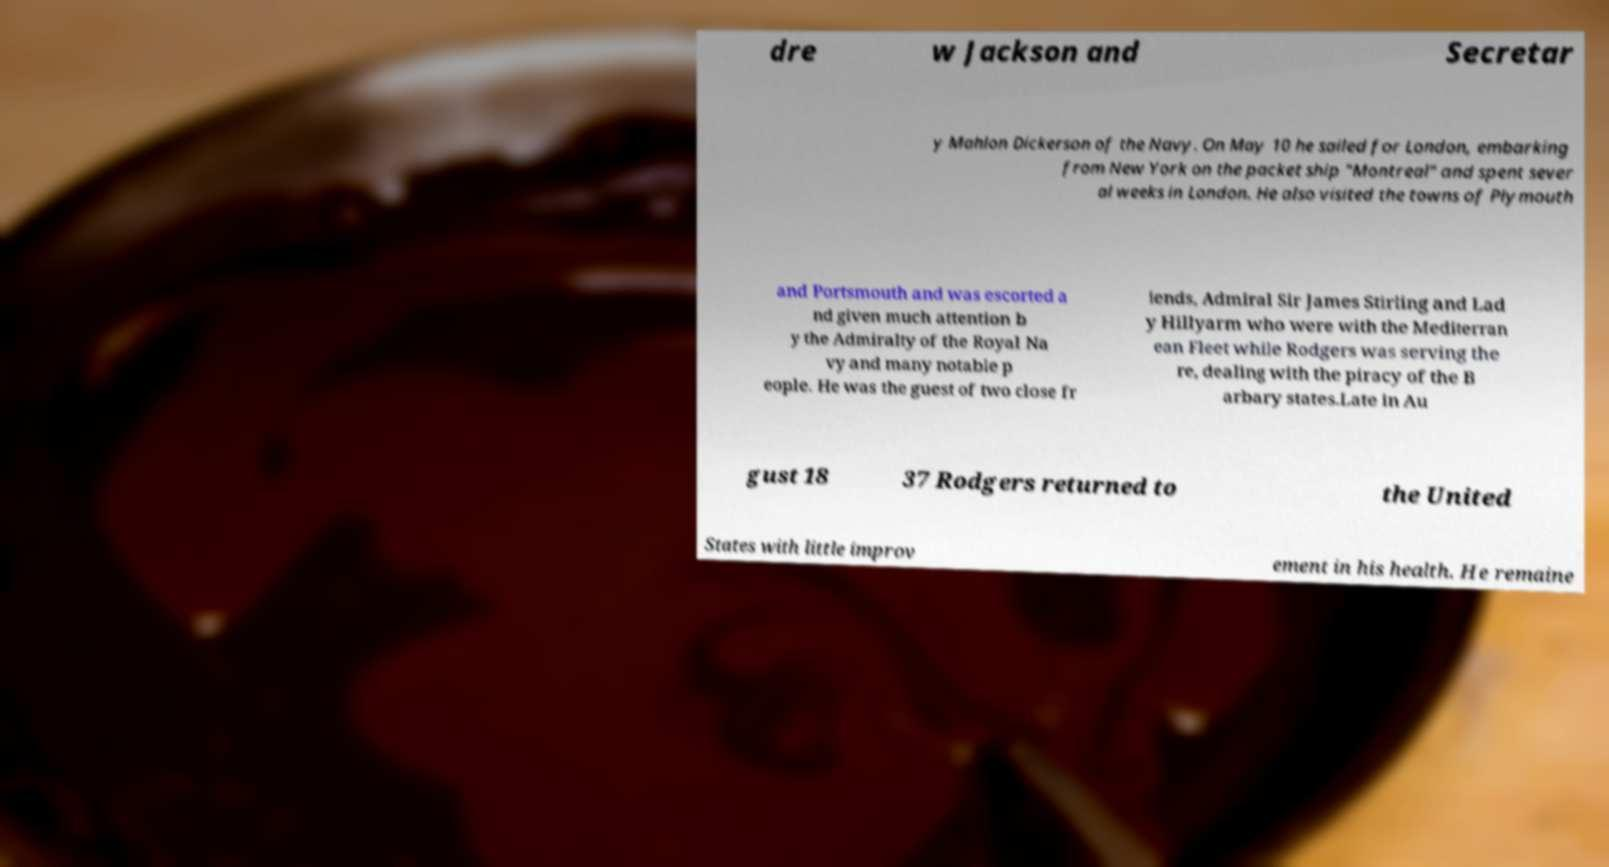For documentation purposes, I need the text within this image transcribed. Could you provide that? dre w Jackson and Secretar y Mahlon Dickerson of the Navy. On May 10 he sailed for London, embarking from New York on the packet ship "Montreal" and spent sever al weeks in London. He also visited the towns of Plymouth and Portsmouth and was escorted a nd given much attention b y the Admiralty of the Royal Na vy and many notable p eople. He was the guest of two close fr iends, Admiral Sir James Stirling and Lad y Hillyarm who were with the Mediterran ean Fleet while Rodgers was serving the re, dealing with the piracy of the B arbary states.Late in Au gust 18 37 Rodgers returned to the United States with little improv ement in his health. He remaine 